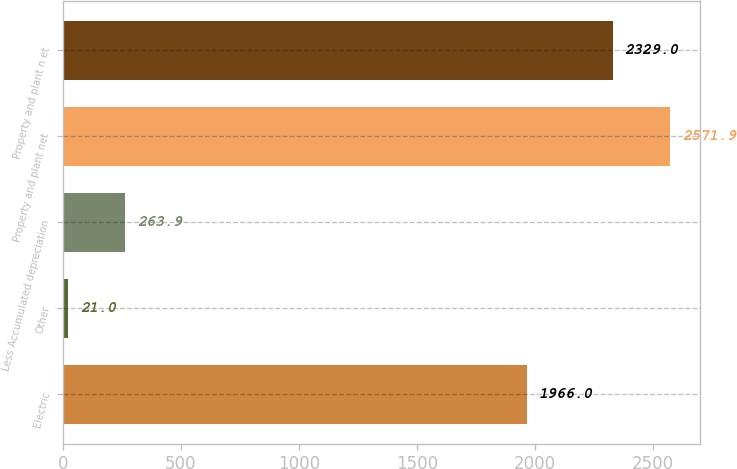Convert chart. <chart><loc_0><loc_0><loc_500><loc_500><bar_chart><fcel>Electric<fcel>Other<fcel>Less Accumulated depreciation<fcel>Property and plant net<fcel>Property and plant n et<nl><fcel>1966<fcel>21<fcel>263.9<fcel>2571.9<fcel>2329<nl></chart> 